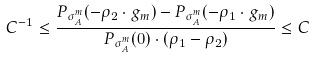<formula> <loc_0><loc_0><loc_500><loc_500>C ^ { - 1 } \leq \frac { P _ { \sigma _ { A } ^ { m } } ( - \rho _ { 2 } \cdot g _ { m } ) - P _ { \sigma _ { A } ^ { m } } ( - \rho _ { 1 } \cdot g _ { m } ) } { P _ { \sigma _ { A } ^ { m } } ( 0 ) \cdot ( \rho _ { 1 } - \rho _ { 2 } ) } \leq C</formula> 